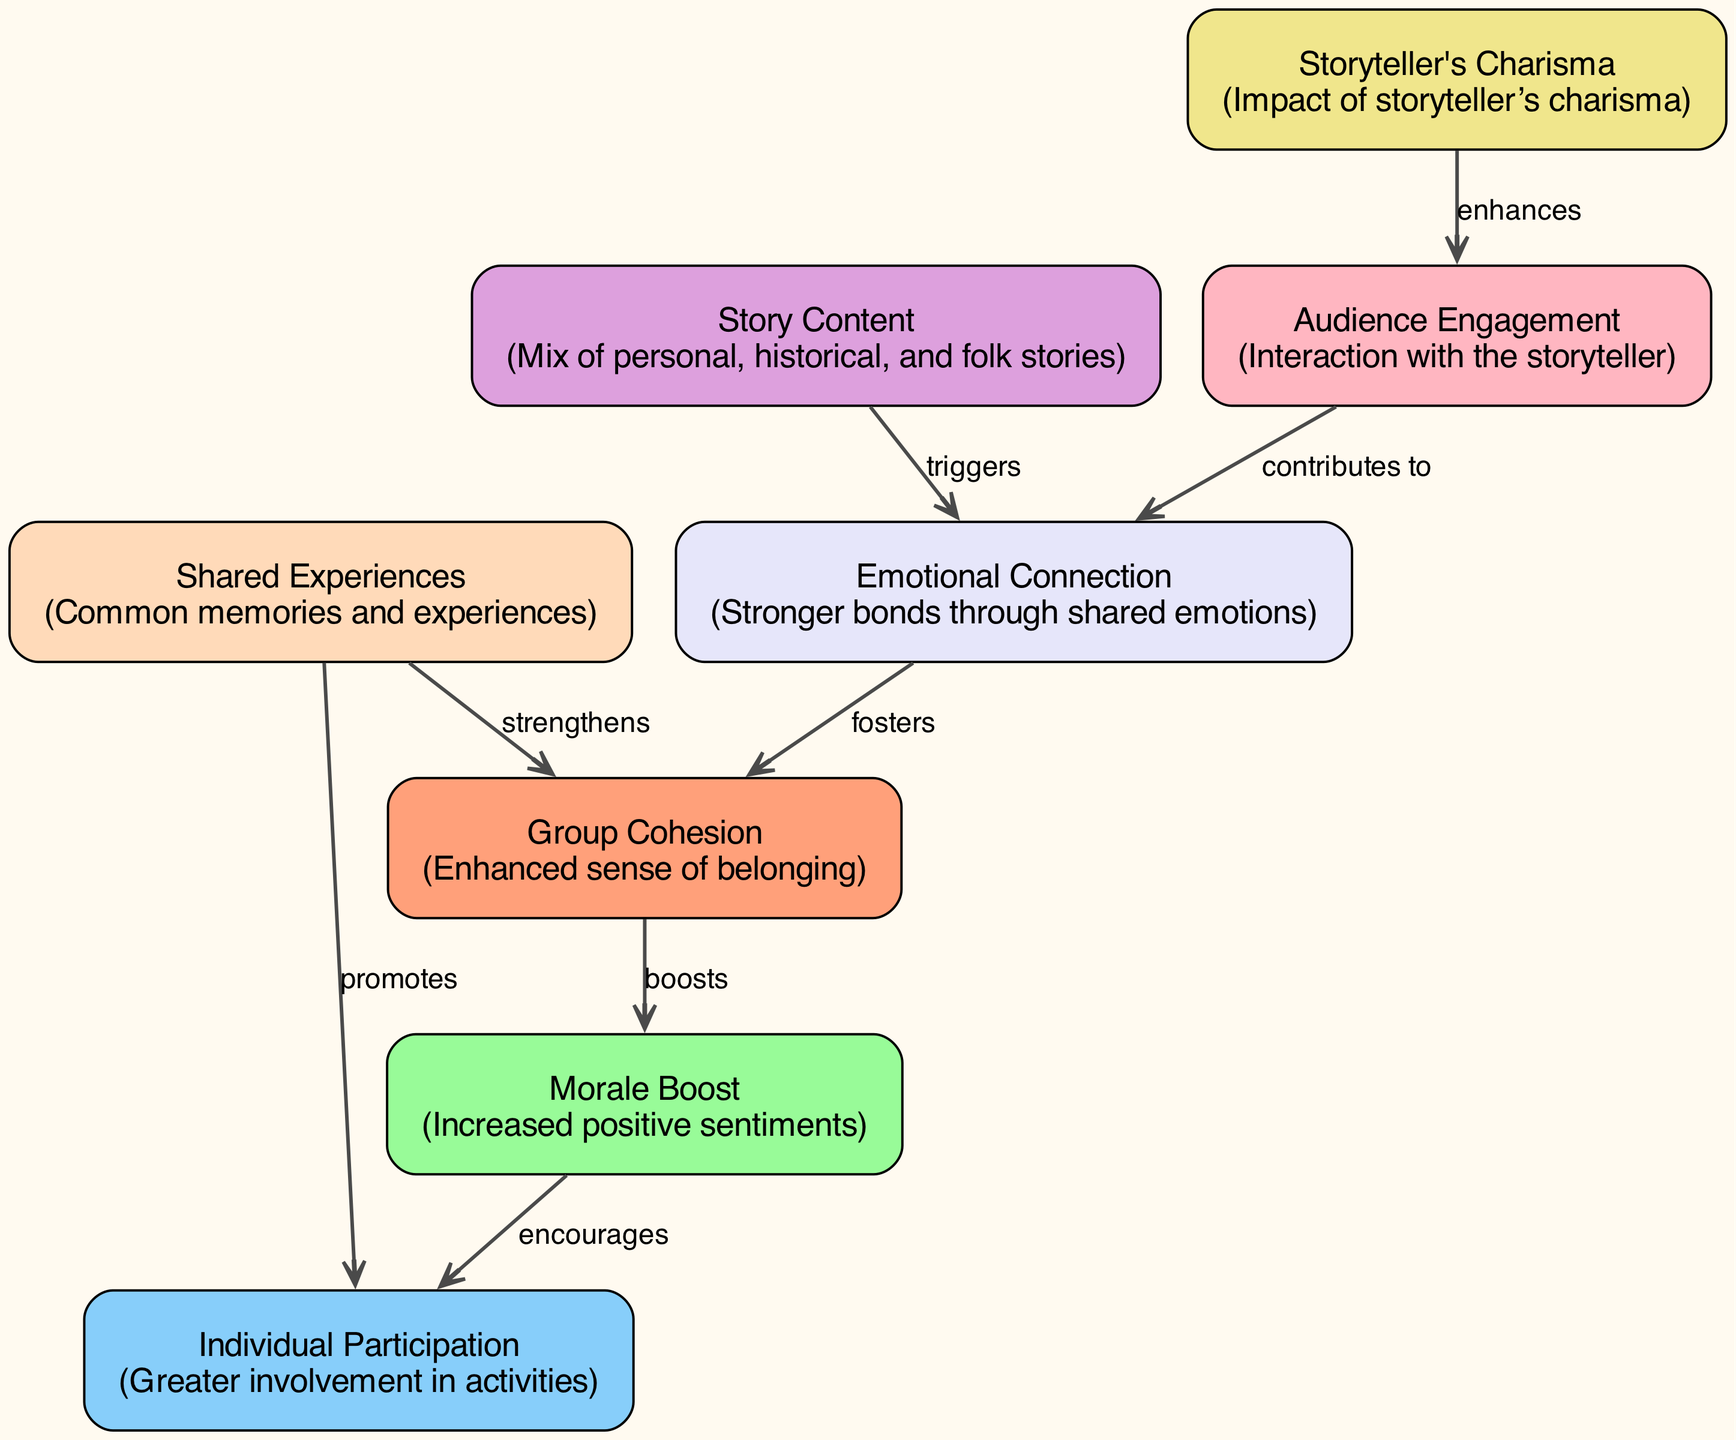What are the three primary nodes represented in the diagram? The diagram consists of eight nodes; the three primary nodes are Group Cohesion, Morale Boost, and Individual Participation, which are significant outcomes of storytelling.
Answer: Group Cohesion, Morale Boost, Individual Participation How many nodes are in the diagram? By counting the items listed in the nodes section of the data, I find that there are eight different nodes represented in the diagram.
Answer: 8 Which node triggers the Emotional Connection? The edge from Story Content to Emotional Connection indicates that the mix of stories shared triggers stronger emotional connections among the group members.
Answer: Story Content What does the edge from Audience Engagement to Emotional Connection contribute to? The edge labeled "contributes to" from Audience Engagement leads to Emotional Connection, demonstrating that the more engaged the audience is, the stronger their emotional connections will be.
Answer: Emotional Connection How does Shared Experiences impact Group Cohesion? The diagram shows an edge labeled "strengthens" from Shared Experiences to Group Cohesion, indicating that when group members share experiences, it reinforces their sense of belonging to the group.
Answer: strengthens What effect does Group Cohesion have on Morale Boost? The connection illustrated in the diagram indicates that Group Cohesion "boosts" Morale Boost, meaning a greater sense of connection among group members results in increased positive sentiments.
Answer: boosts Which node enhances Audience Engagement? The diagram shows that Storyteller's Charisma enhances Audience Engagement, indicating that a storyteller who captivates the audience effectively encourages them to participate and engage more deeply.
Answer: Storyteller's Charisma Name the process that encourages Individual Participation. The diagram indicates that Morale Boost encourages Individual Participation, meaning that higher morale leads to more active involvement in group activities.
Answer: encourages What type of stories are included in Story Content? The description of Story Content mentions that it consists of a mix of personal, historical, and folk stories which play a vital role in engaging the audience and establishing emotional connections.
Answer: Personal, historical, and folk stories 